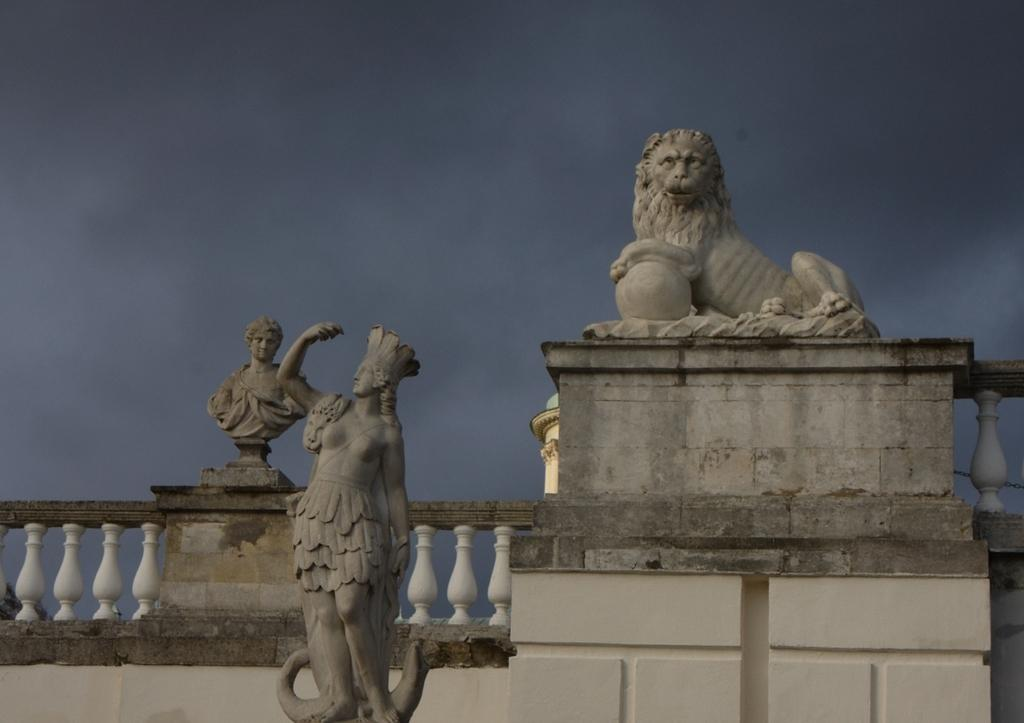What type of objects can be seen in the image? There are statues in the image. What can be seen in the background of the image? There is a railing in the background of the image. What is visible at the top of the image? The sky is visible at the top of the image. What type of fuel is being used by the fireman in the image? There is no fireman present in the image, so it is not possible to determine what type of fuel they might be using. 